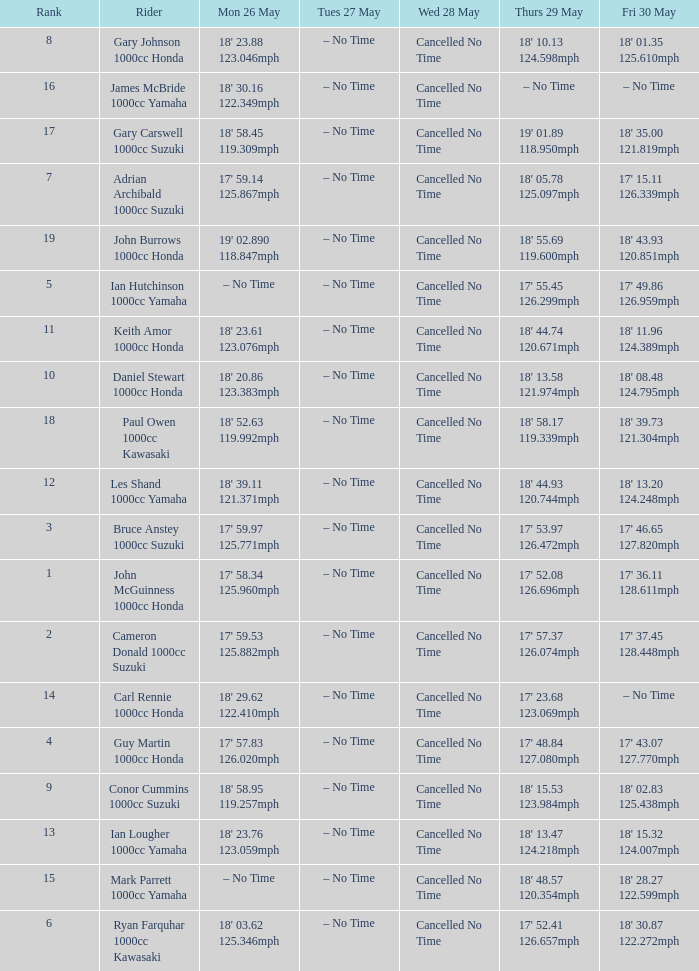What is the numbr for fri may 30 and mon may 26 is 19' 02.890 118.847mph? 18' 43.93 120.851mph. 